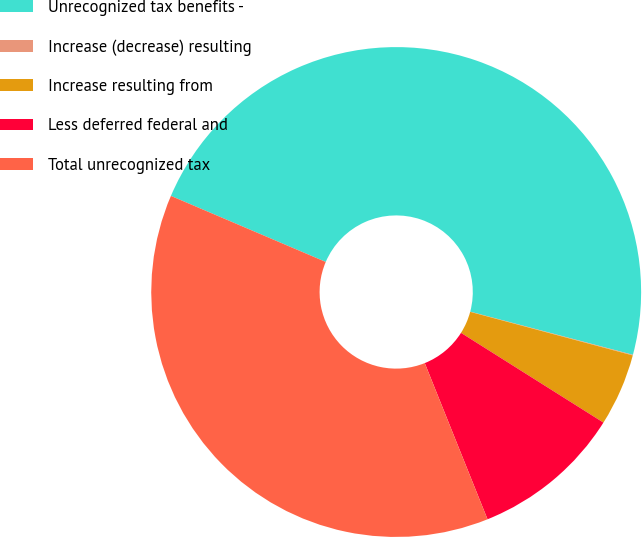Convert chart. <chart><loc_0><loc_0><loc_500><loc_500><pie_chart><fcel>Unrecognized tax benefits -<fcel>Increase (decrease) resulting<fcel>Increase resulting from<fcel>Less deferred federal and<fcel>Total unrecognized tax<nl><fcel>47.71%<fcel>0.04%<fcel>4.78%<fcel>9.97%<fcel>37.5%<nl></chart> 